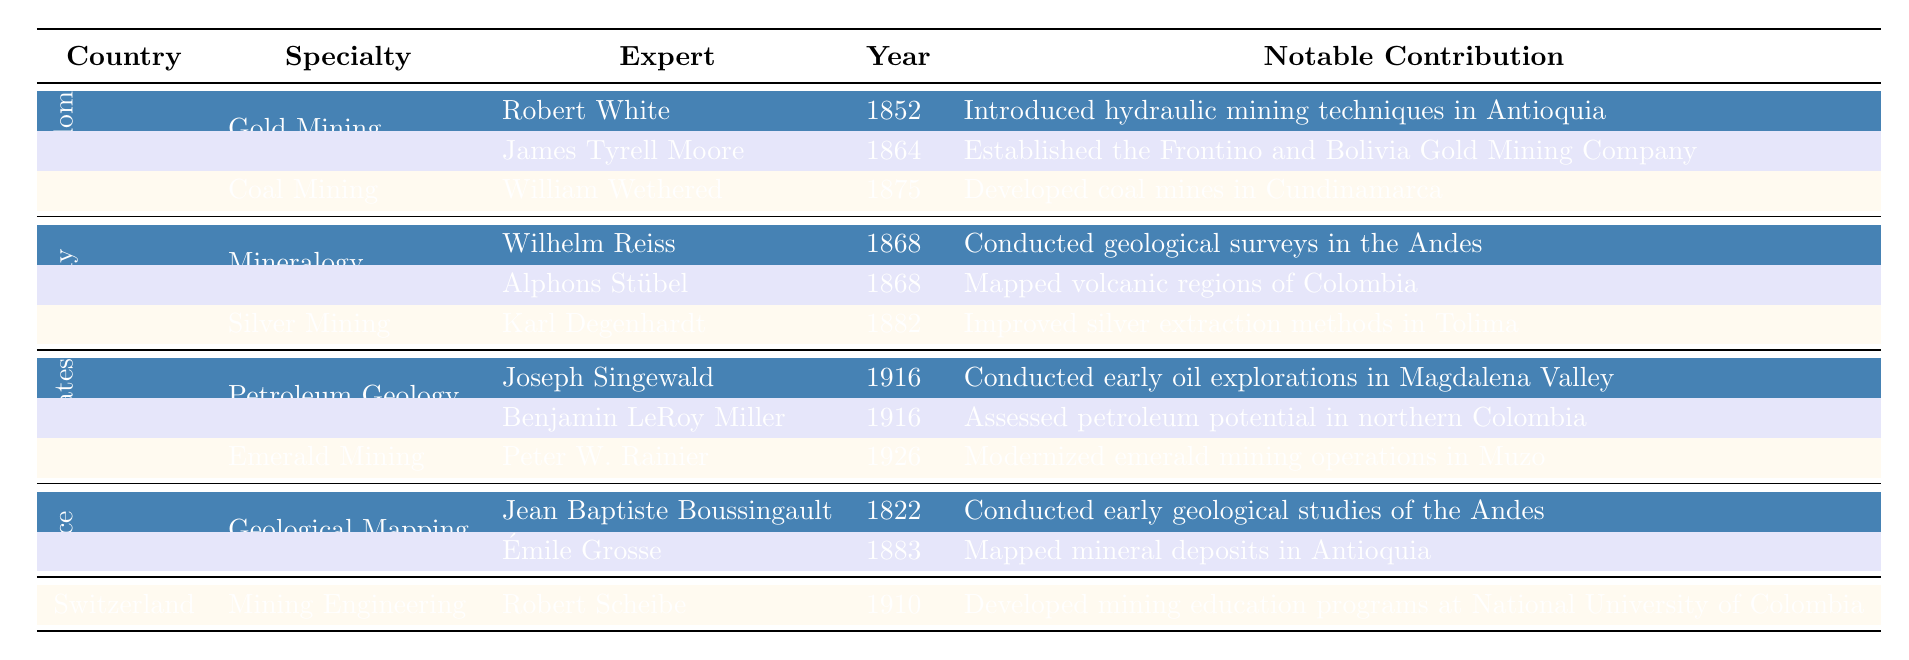What was the notable contribution of Robert White? According to the table, Robert White arrived in 1852 and introduced hydraulic mining techniques in Antioquia, which is mentioned under his notable contribution.
Answer: Introduced hydraulic mining techniques in Antioquia How many experts contributed to gold mining from the United Kingdom? The table lists two experts under the specialty of gold mining from the United Kingdom: Robert White and James Tyrell Moore. Thus, the total is 2.
Answer: 2 True or False: Karl Degenhardt was involved in coal mining. The table shows that Karl Degenhardt specialized in silver mining, not coal mining. Therefore, this statement is false.
Answer: False Which country's experts were involved in the geological mapping specialty? The table indicates that experts from France, specifically Jean Baptiste Boussingault and Émile Grosse, were involved in geological mapping.
Answer: France What is the year of arrival of the expert who modernized emerald mining operations in Muzo? The table notes that Peter W. Rainier, who modernized emerald mining operations, arrived in 1926.
Answer: 1926 How many total specialties are represented by German experts in the table? The table shows that there are two specialties represented by German experts: mineralogy and silver mining. So, the total is 2.
Answer: 2 Identify the first expert who conducted early geological studies of the Andes and the year he arrived. The table lists Jean Baptiste Boussingault as the first expert for geological studies of the Andes, arriving in 1822.
Answer: Jean Baptiste Boussingault, 1822 Which foreign expert made contributions to both emerald mining and petroleum geology, and in what years did they arrive? The table mentions that no single expert contributed to both specializations; therefore, the answer is none.
Answer: None What notable contributions did United States experts provide regarding petroleum? According to the table, Joseph Singewald and Benjamin LeRoy Miller contributed to early oil explorations and assessed petroleum potential in northern Colombia, respectively.
Answer: Early oil explorations and assessed petroleum potential How many total experts are listed under the specialty of coal mining across all countries? The table indicates only one expert, William Wethered, under coal mining from the United Kingdom. Therefore, the total is 1.
Answer: 1 Which expert arrived in 1910, and what was his notable contribution? The table states that Robert Scheibe arrived in 1910 and developed mining education programs at the National University of Colombia.
Answer: Robert Scheibe, developed mining education programs 